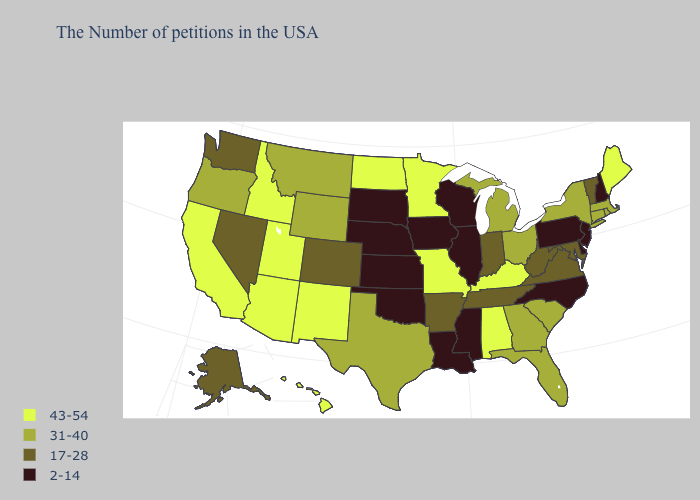Among the states that border Nebraska , which have the highest value?
Write a very short answer. Missouri. What is the value of Minnesota?
Short answer required. 43-54. Among the states that border Washington , which have the lowest value?
Answer briefly. Oregon. Does South Dakota have the lowest value in the USA?
Answer briefly. Yes. Which states hav the highest value in the Northeast?
Give a very brief answer. Maine. Name the states that have a value in the range 17-28?
Be succinct. Vermont, Maryland, Virginia, West Virginia, Indiana, Tennessee, Arkansas, Colorado, Nevada, Washington, Alaska. Which states have the lowest value in the Northeast?
Concise answer only. New Hampshire, New Jersey, Pennsylvania. Does the map have missing data?
Answer briefly. No. Does Florida have a higher value than Minnesota?
Be succinct. No. Is the legend a continuous bar?
Give a very brief answer. No. Which states have the lowest value in the Northeast?
Be succinct. New Hampshire, New Jersey, Pennsylvania. Does Maine have the highest value in the Northeast?
Keep it brief. Yes. Which states have the lowest value in the MidWest?
Short answer required. Wisconsin, Illinois, Iowa, Kansas, Nebraska, South Dakota. Which states have the highest value in the USA?
Quick response, please. Maine, Kentucky, Alabama, Missouri, Minnesota, North Dakota, New Mexico, Utah, Arizona, Idaho, California, Hawaii. Among the states that border Louisiana , does Texas have the highest value?
Be succinct. Yes. 